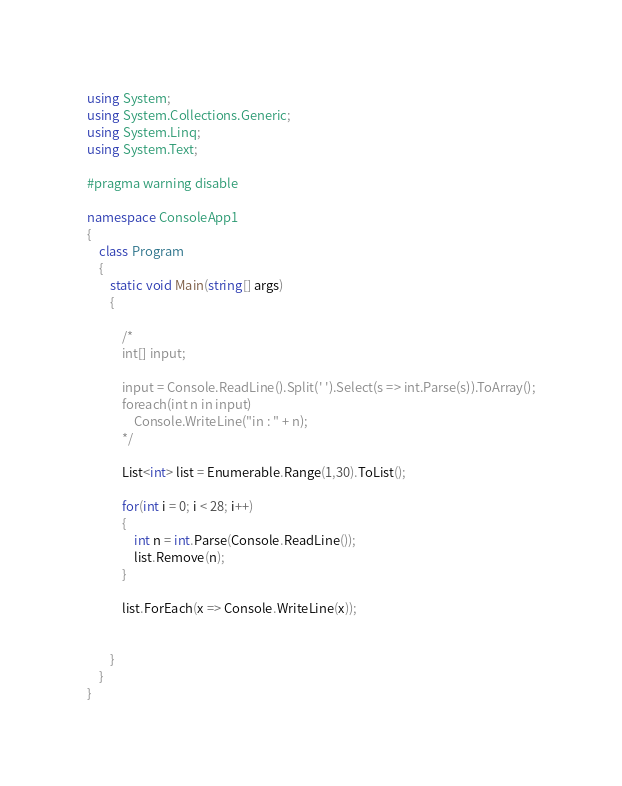<code> <loc_0><loc_0><loc_500><loc_500><_C#_>using System;
using System.Collections.Generic;
using System.Linq;
using System.Text;

#pragma warning disable

namespace ConsoleApp1
{
    class Program
    {
        static void Main(string[] args)
        {

            /*
            int[] input;

            input = Console.ReadLine().Split(' ').Select(s => int.Parse(s)).ToArray();
            foreach(int n in input)
                Console.WriteLine("in : " + n);
            */

            List<int> list = Enumerable.Range(1,30).ToList();

            for(int i = 0; i < 28; i++)
            {
                int n = int.Parse(Console.ReadLine());
                list.Remove(n);
            }

            list.ForEach(x => Console.WriteLine(x));


        }
    }
}</code> 